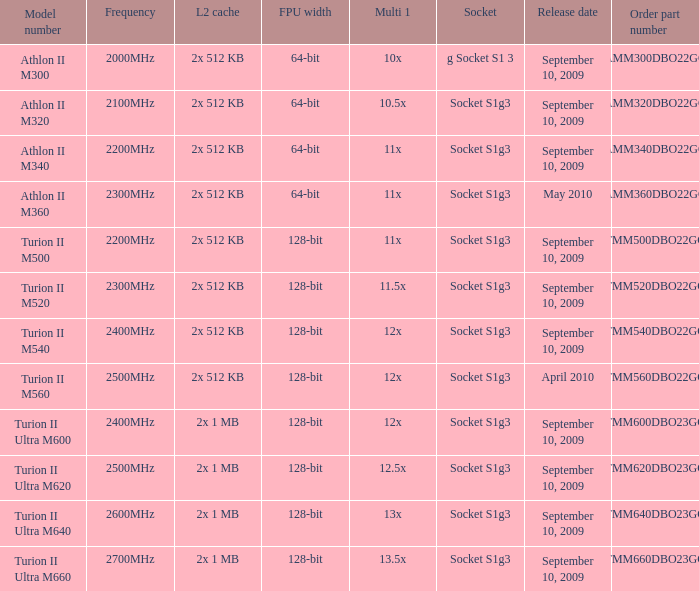5x multiplier 1? 2x 1 MB. 